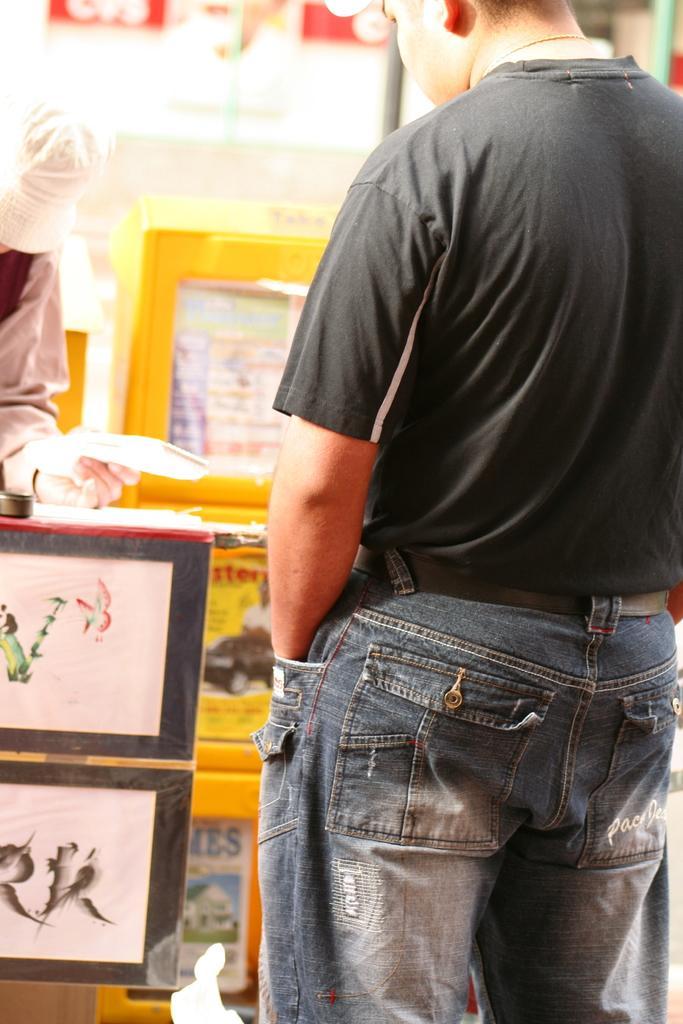In one or two sentences, can you explain what this image depicts? In this picture we can see two people, here we can see the wall, photo frames and few objects. 